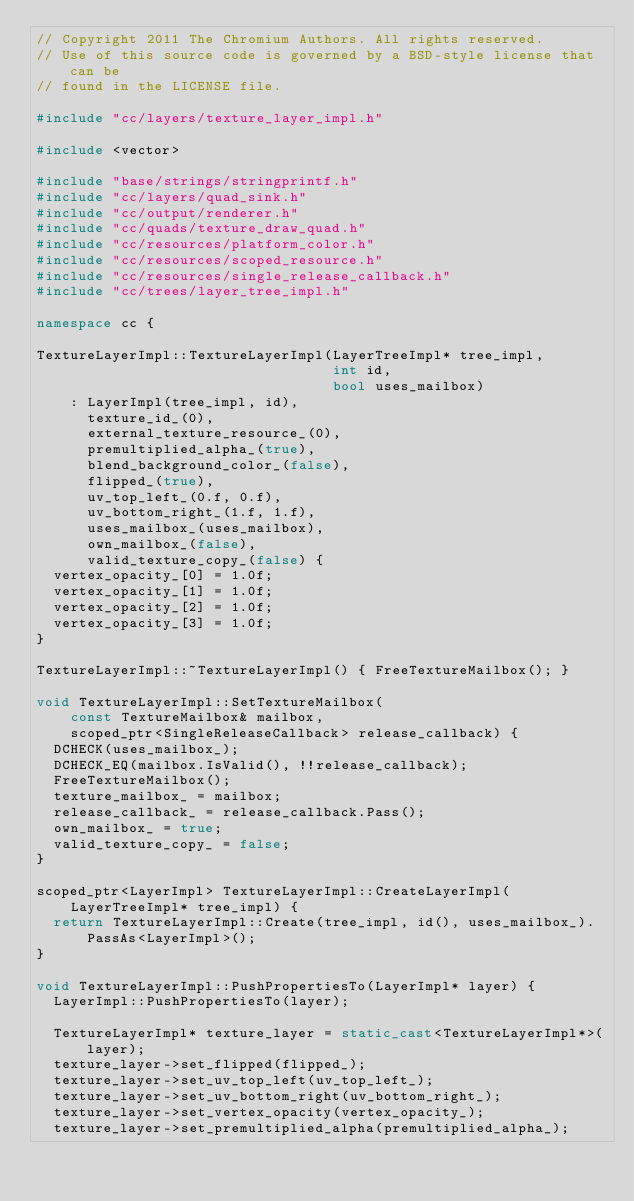Convert code to text. <code><loc_0><loc_0><loc_500><loc_500><_C++_>// Copyright 2011 The Chromium Authors. All rights reserved.
// Use of this source code is governed by a BSD-style license that can be
// found in the LICENSE file.

#include "cc/layers/texture_layer_impl.h"

#include <vector>

#include "base/strings/stringprintf.h"
#include "cc/layers/quad_sink.h"
#include "cc/output/renderer.h"
#include "cc/quads/texture_draw_quad.h"
#include "cc/resources/platform_color.h"
#include "cc/resources/scoped_resource.h"
#include "cc/resources/single_release_callback.h"
#include "cc/trees/layer_tree_impl.h"

namespace cc {

TextureLayerImpl::TextureLayerImpl(LayerTreeImpl* tree_impl,
                                   int id,
                                   bool uses_mailbox)
    : LayerImpl(tree_impl, id),
      texture_id_(0),
      external_texture_resource_(0),
      premultiplied_alpha_(true),
      blend_background_color_(false),
      flipped_(true),
      uv_top_left_(0.f, 0.f),
      uv_bottom_right_(1.f, 1.f),
      uses_mailbox_(uses_mailbox),
      own_mailbox_(false),
      valid_texture_copy_(false) {
  vertex_opacity_[0] = 1.0f;
  vertex_opacity_[1] = 1.0f;
  vertex_opacity_[2] = 1.0f;
  vertex_opacity_[3] = 1.0f;
}

TextureLayerImpl::~TextureLayerImpl() { FreeTextureMailbox(); }

void TextureLayerImpl::SetTextureMailbox(
    const TextureMailbox& mailbox,
    scoped_ptr<SingleReleaseCallback> release_callback) {
  DCHECK(uses_mailbox_);
  DCHECK_EQ(mailbox.IsValid(), !!release_callback);
  FreeTextureMailbox();
  texture_mailbox_ = mailbox;
  release_callback_ = release_callback.Pass();
  own_mailbox_ = true;
  valid_texture_copy_ = false;
}

scoped_ptr<LayerImpl> TextureLayerImpl::CreateLayerImpl(
    LayerTreeImpl* tree_impl) {
  return TextureLayerImpl::Create(tree_impl, id(), uses_mailbox_).
      PassAs<LayerImpl>();
}

void TextureLayerImpl::PushPropertiesTo(LayerImpl* layer) {
  LayerImpl::PushPropertiesTo(layer);

  TextureLayerImpl* texture_layer = static_cast<TextureLayerImpl*>(layer);
  texture_layer->set_flipped(flipped_);
  texture_layer->set_uv_top_left(uv_top_left_);
  texture_layer->set_uv_bottom_right(uv_bottom_right_);
  texture_layer->set_vertex_opacity(vertex_opacity_);
  texture_layer->set_premultiplied_alpha(premultiplied_alpha_);</code> 